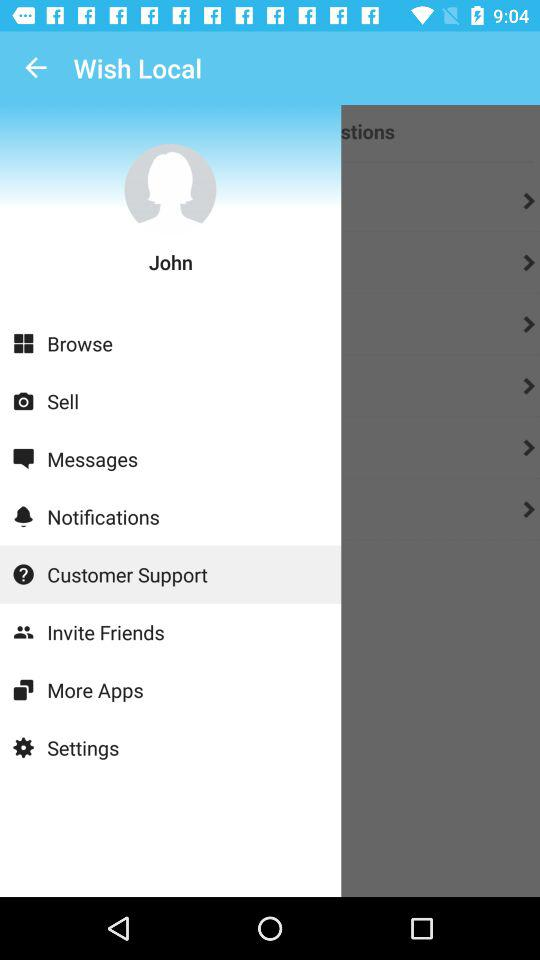What is the user's name? The user's name is John. 